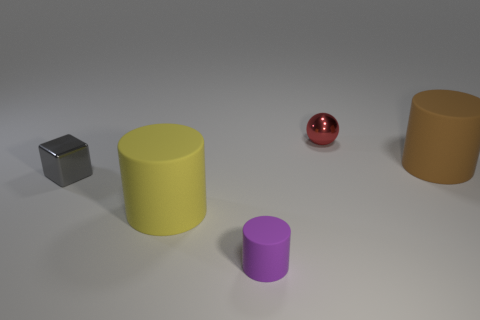Subtract all big cylinders. How many cylinders are left? 1 Add 2 tiny red metal spheres. How many objects exist? 7 Subtract 0 green blocks. How many objects are left? 5 Subtract all blocks. How many objects are left? 4 Subtract all tiny red metallic cylinders. Subtract all small balls. How many objects are left? 4 Add 1 tiny matte objects. How many tiny matte objects are left? 2 Add 2 tiny gray metal cubes. How many tiny gray metal cubes exist? 3 